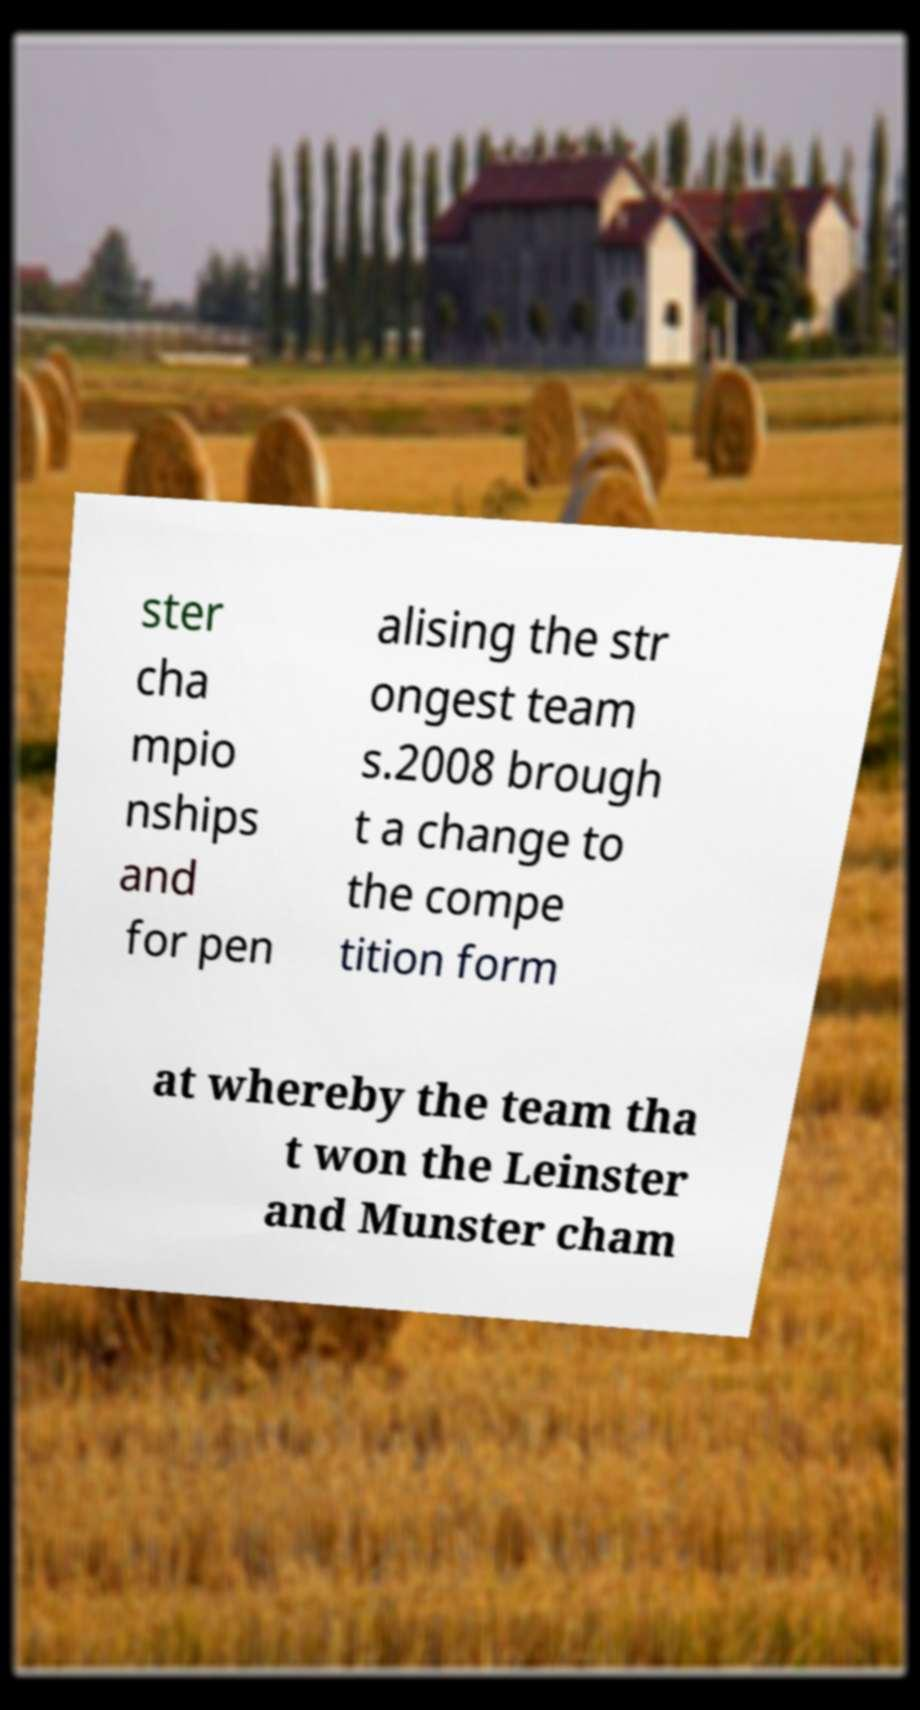Could you assist in decoding the text presented in this image and type it out clearly? ster cha mpio nships and for pen alising the str ongest team s.2008 brough t a change to the compe tition form at whereby the team tha t won the Leinster and Munster cham 